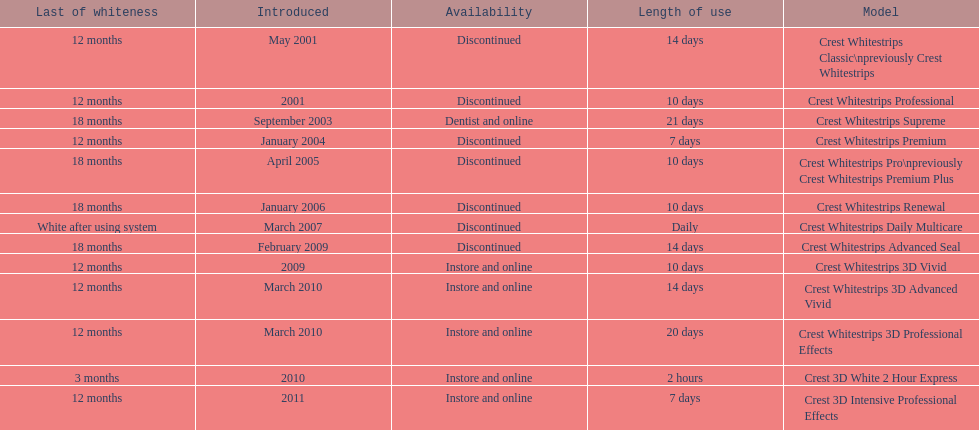What product was introduced in the same month as crest whitestrips 3d advanced vivid? Crest Whitestrips 3D Professional Effects. 